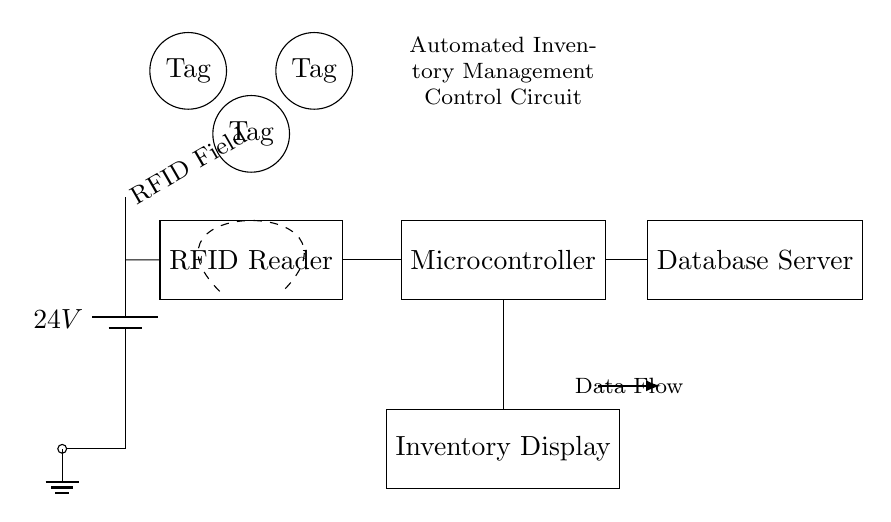What is the voltage source in this circuit? The voltage source is a battery indicated on the left side of the diagram. It is labeled as twenty-four volts, which shows the potential difference supplied to the circuit components.
Answer: twenty-four volts What component connects the RFID Reader and the Microcontroller? The two components are connected directly by a line, indicating a wire with an electrical connection without any other components in between. This direct connection allows the microcontroller to receive data from the RFID reader.
Answer: wire How many RFID Tags are represented in the circuit? There are three RFID Tags shown in the diagram, represented as three distinct circular nodes placed above the RFID Reader within the RFID Field.
Answer: three What role does the Database Server play in the circuit? The Database Server receives data directly from the Microcontroller, serving as a storage and management system that updates the inventory based on information from the RFID Reader through the Microcontroller.
Answer: storage What is the purpose of the Inventory Display? The Inventory Display is connected to the Microcontroller, which sends information about current inventory levels to be shown to the user. This allows for real-time monitoring of stock quantities.
Answer: real-time monitoring What does the dashed line represent in this circuit? The dashed line indicates the range of the RFID Field. This line shows the area within which the RFID Tags can be successfully read by the RFID Reader, representing the effective distance for RFID detection.
Answer: RFID Field 